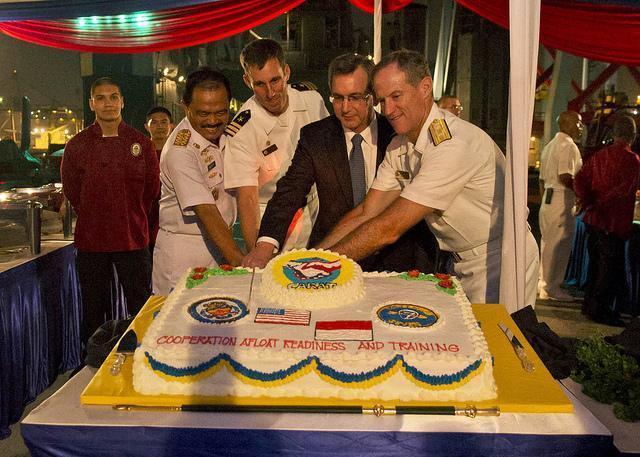How many people can be seen?
Give a very brief answer. 7. 